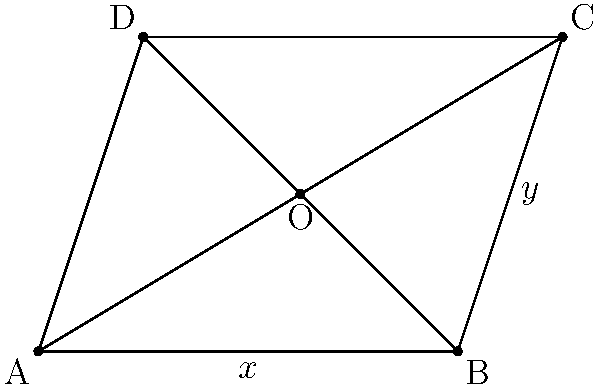In the rhombus ABCD shown above, if the length of diagonal AC is 6 units and the area of the rhombus is 12 square units, determine the length of side AB. How might this geometric problem inspire a metaphor in your writing about perseverance and balance? Let's approach this step-by-step:

1) In a rhombus, the diagonals bisect each other at right angles. Let O be the point of intersection of the diagonals.

2) Let's denote the length of diagonal BD as 2x and the length of diagonal AC as 2y. We're given that AC = 6, so y = 3.

3) The area of a rhombus is given by the formula: 
   $$\text{Area} = \frac{1}{2} \times (\text{diagonal 1}) \times (\text{diagonal 2})$$

4) Substituting the known values:
   $$12 = \frac{1}{2} \times 6 \times 2x$$

5) Simplifying:
   $$12 = 6x$$
   $$x = 2$$

6) So, diagonal BD = 2x = 4

7) In a rhombus, we can use the Pythagorean theorem to find the side length:
   $$\text{side}^2 = x^2 + y^2$$

8) Substituting the values:
   $$\text{side}^2 = 2^2 + 3^2 = 4 + 9 = 13$$

9) Taking the square root:
   $$\text{side} = \sqrt{13}$$

This problem demonstrates how different aspects of a shape (diagonals, area, sides) are interconnected, much like the elements of a story. The balance between the diagonals to create a specific area could be seen as a metaphor for how different narrative elements must be balanced to create a compelling story. The process of solving for the unknown side length could represent the perseverance needed in writing to uncover the hidden depths of characters or plot.
Answer: $\sqrt{13}$ units 